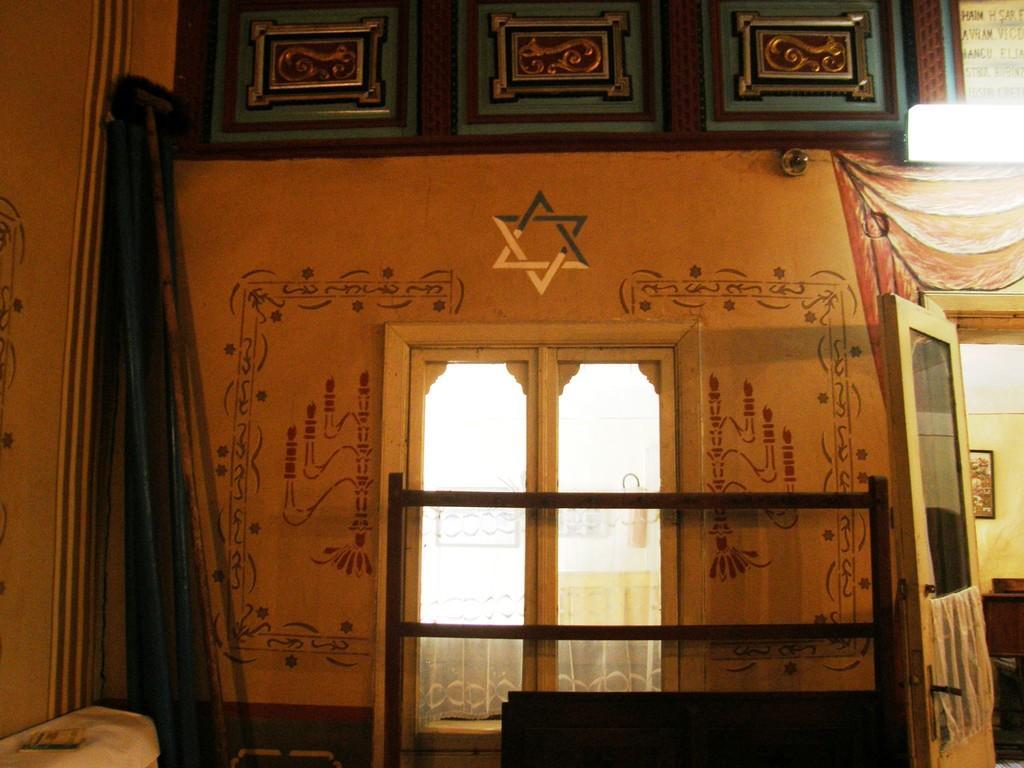How would you summarize this image in a sentence or two? The picture is clicked inside a room. On the wall there are paintings. There is a glass window. In the right there is a door. Inside the room there are furniture. 